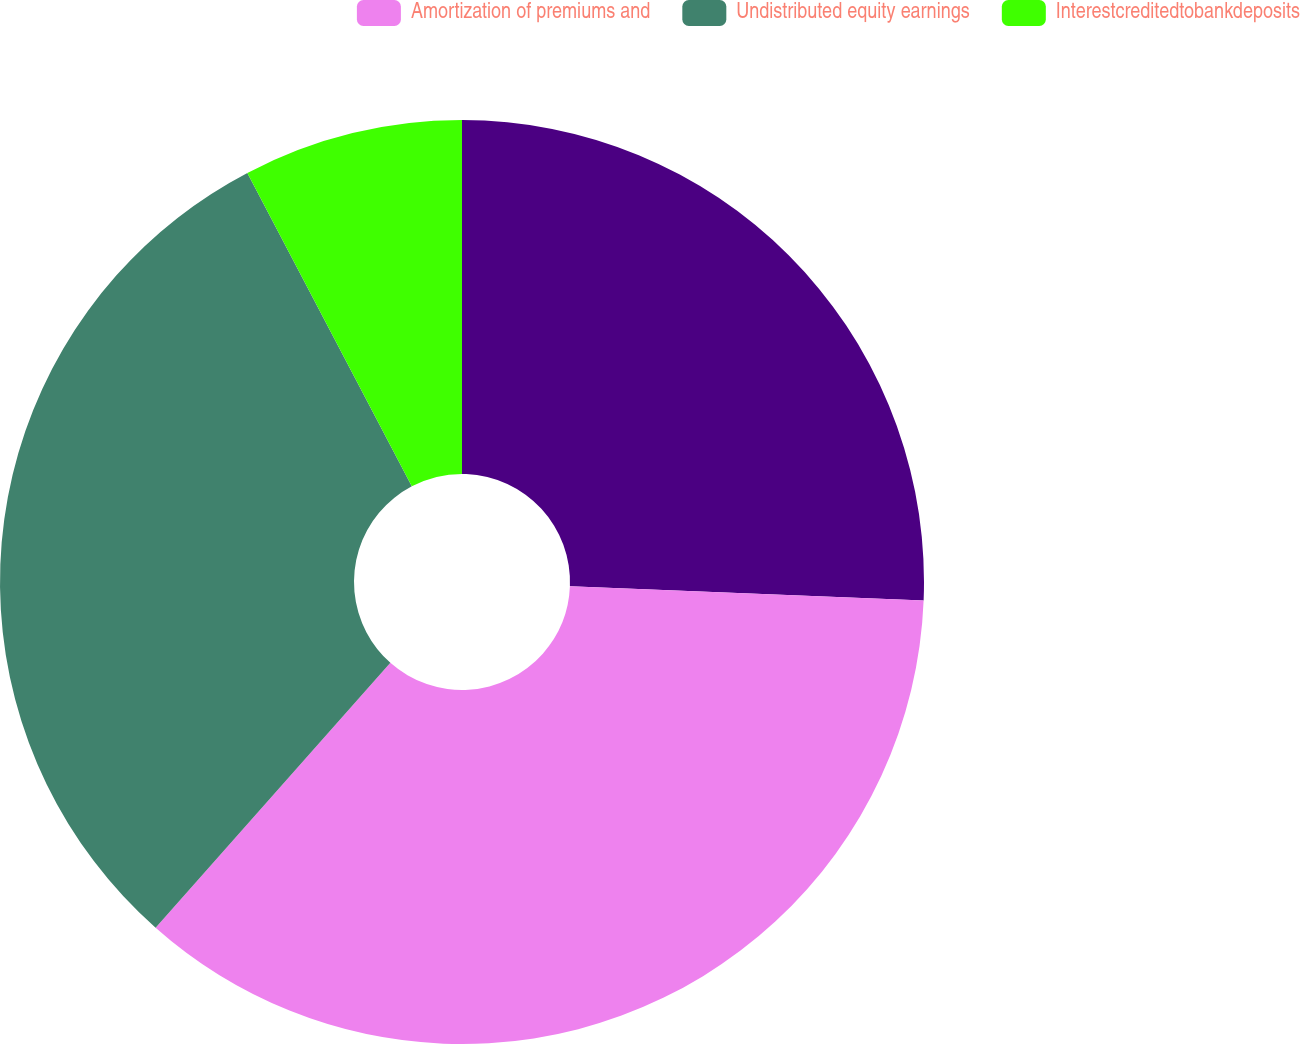Convert chart. <chart><loc_0><loc_0><loc_500><loc_500><pie_chart><ecel><fcel>Amortization of premiums and<fcel>Undistributed equity earnings<fcel>Interestcreditedtobankdeposits<nl><fcel>25.64%<fcel>35.9%<fcel>30.77%<fcel>7.69%<nl></chart> 